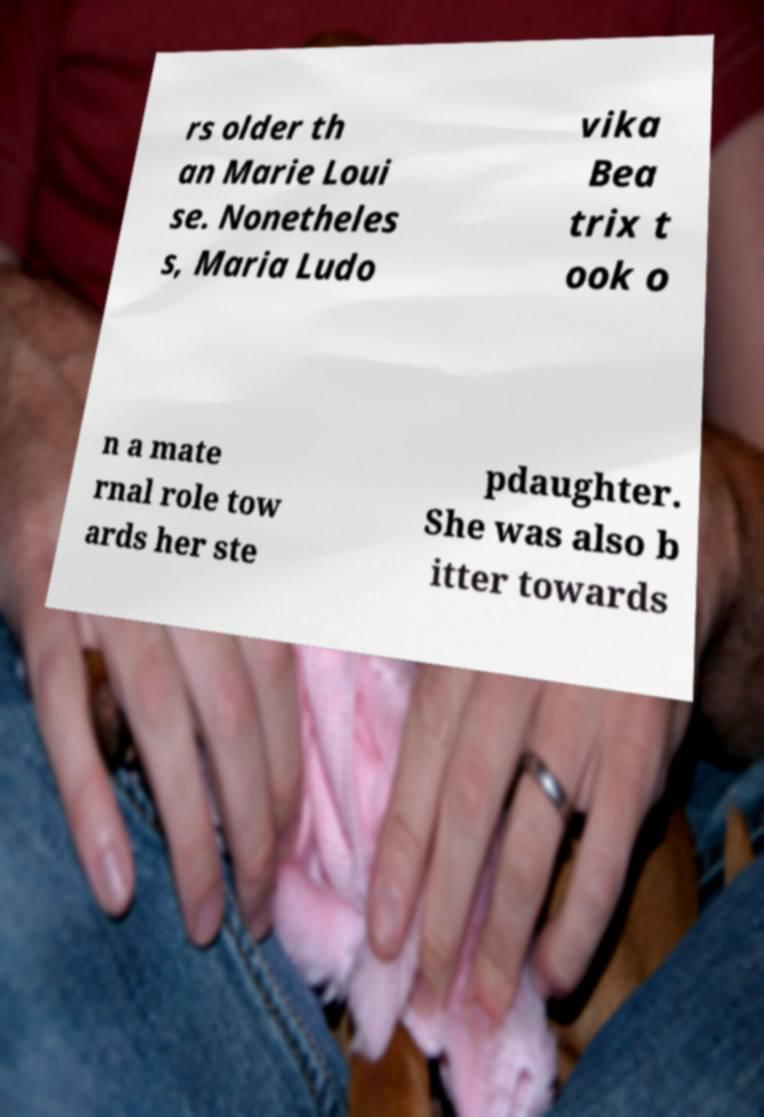Can you accurately transcribe the text from the provided image for me? rs older th an Marie Loui se. Nonetheles s, Maria Ludo vika Bea trix t ook o n a mate rnal role tow ards her ste pdaughter. She was also b itter towards 